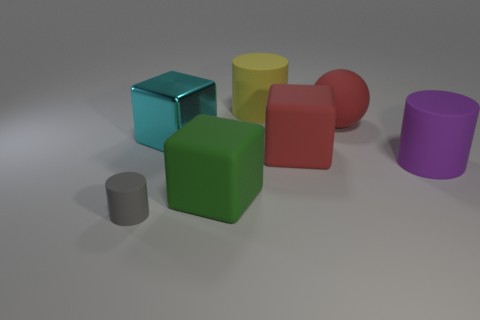Is there any other thing that is the same size as the gray matte thing?
Keep it short and to the point. No. Are there fewer gray cylinders than big rubber blocks?
Your answer should be very brief. Yes. There is a large thing that is in front of the cylinder that is right of the large block to the right of the yellow matte cylinder; what is its shape?
Make the answer very short. Cube. How many things are big blocks that are on the right side of the yellow object or rubber cylinders that are behind the gray cylinder?
Give a very brief answer. 3. There is a rubber ball; are there any big cylinders behind it?
Offer a very short reply. Yes. What number of things are either matte objects right of the big red rubber ball or small cylinders?
Offer a very short reply. 2. How many gray things are either small rubber cylinders or big rubber spheres?
Ensure brevity in your answer.  1. What number of other objects are the same color as the large sphere?
Ensure brevity in your answer.  1. Is the number of big green matte things behind the big sphere less than the number of large purple rubber cylinders?
Offer a very short reply. Yes. The rubber cube in front of the cylinder that is right of the large red thing that is in front of the large shiny cube is what color?
Offer a very short reply. Green. 